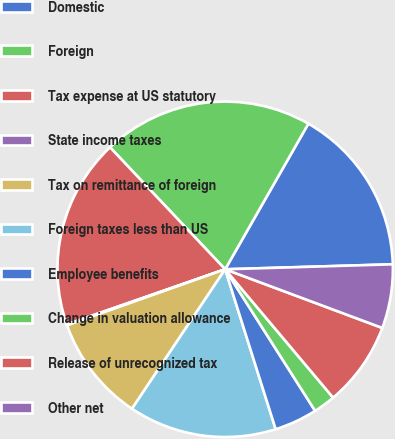<chart> <loc_0><loc_0><loc_500><loc_500><pie_chart><fcel>Domestic<fcel>Foreign<fcel>Tax expense at US statutory<fcel>State income taxes<fcel>Tax on remittance of foreign<fcel>Foreign taxes less than US<fcel>Employee benefits<fcel>Change in valuation allowance<fcel>Release of unrecognized tax<fcel>Other net<nl><fcel>16.26%<fcel>20.3%<fcel>18.28%<fcel>0.1%<fcel>10.2%<fcel>14.24%<fcel>4.14%<fcel>2.12%<fcel>8.18%<fcel>6.16%<nl></chart> 